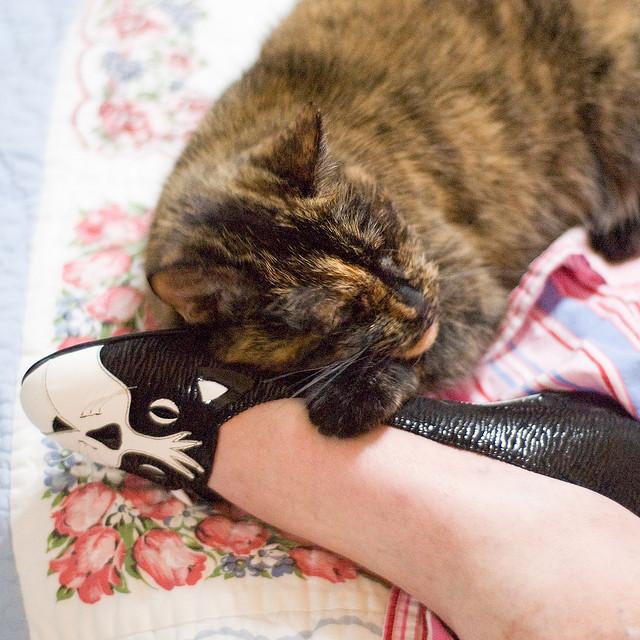What color is the cat?
Give a very brief answer. Brown. Is the person caucasian?
Keep it brief. Yes. Where is the cat sitting?
Keep it brief. Bed. Are the cat's eyes open?
Answer briefly. No. What is the cat doing?
Answer briefly. Sleeping. Does this tortoiseshell cat think the slipper is another cat?
Give a very brief answer. No. What kind of animal is present on the shoe?
Write a very short answer. Cat. 